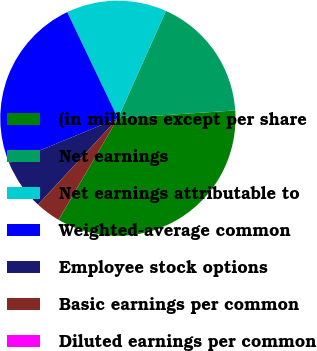Convert chart. <chart><loc_0><loc_0><loc_500><loc_500><pie_chart><fcel>(in millions except per share<fcel>Net earnings<fcel>Net earnings attributable to<fcel>Weighted-average common<fcel>Employee stock options<fcel>Basic earnings per common<fcel>Diluted earnings per common<nl><fcel>34.46%<fcel>17.24%<fcel>13.79%<fcel>24.13%<fcel>6.9%<fcel>3.46%<fcel>0.01%<nl></chart> 